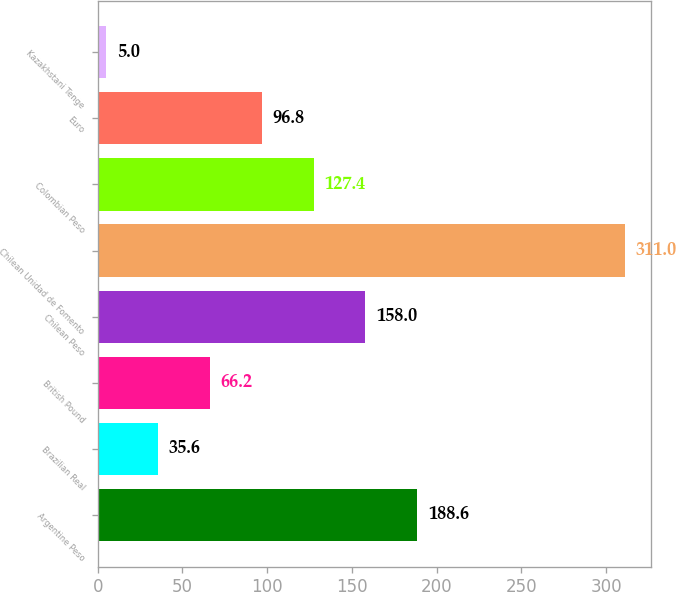Convert chart. <chart><loc_0><loc_0><loc_500><loc_500><bar_chart><fcel>Argentine Peso<fcel>Brazilian Real<fcel>British Pound<fcel>Chilean Peso<fcel>Chilean Unidad de Fomento<fcel>Colombian Peso<fcel>Euro<fcel>Kazakhstani Tenge<nl><fcel>188.6<fcel>35.6<fcel>66.2<fcel>158<fcel>311<fcel>127.4<fcel>96.8<fcel>5<nl></chart> 